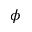<formula> <loc_0><loc_0><loc_500><loc_500>\phi</formula> 